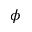<formula> <loc_0><loc_0><loc_500><loc_500>\phi</formula> 